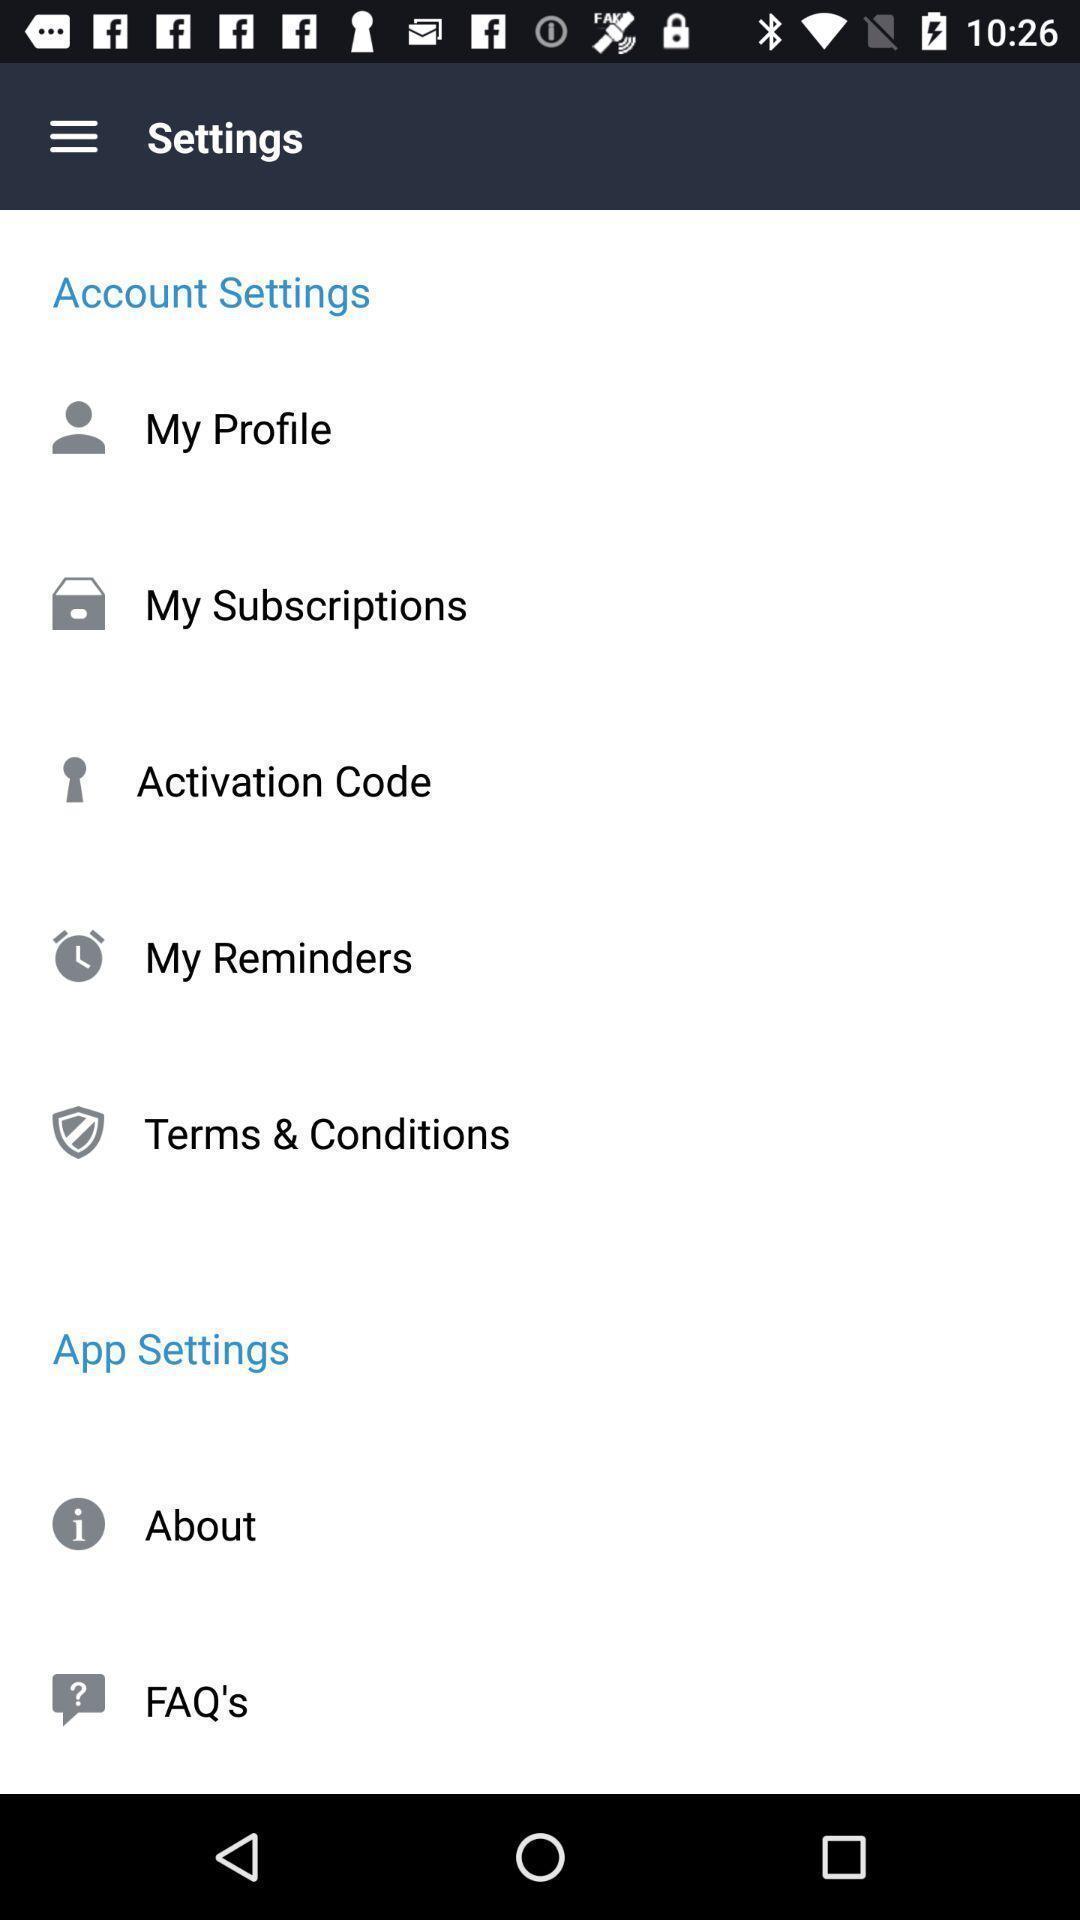Explain what's happening in this screen capture. Settings page. 